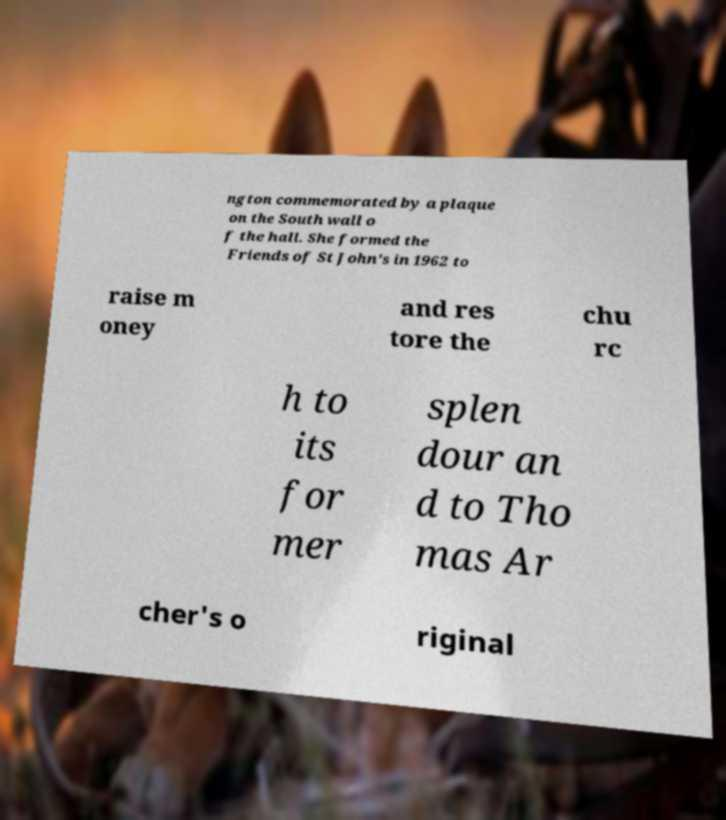Can you read and provide the text displayed in the image?This photo seems to have some interesting text. Can you extract and type it out for me? ngton commemorated by a plaque on the South wall o f the hall. She formed the Friends of St John's in 1962 to raise m oney and res tore the chu rc h to its for mer splen dour an d to Tho mas Ar cher's o riginal 